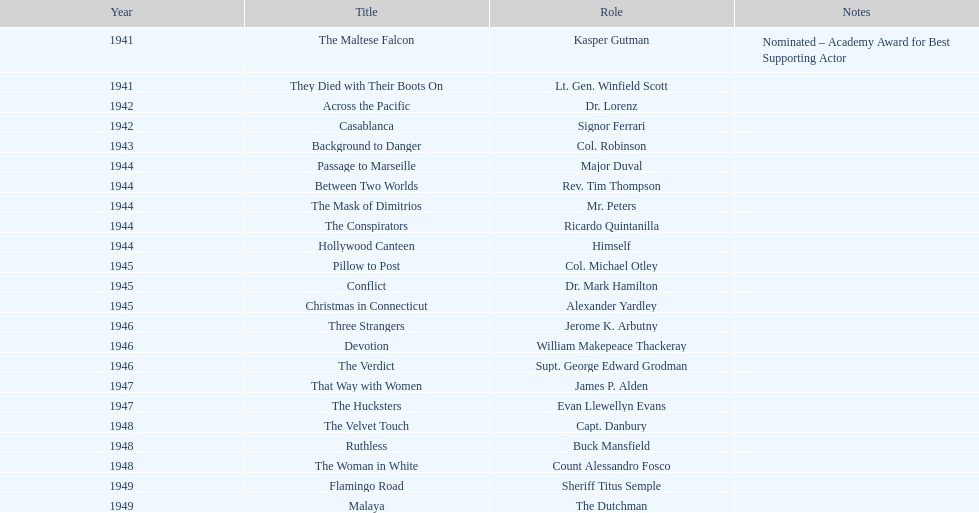What are all of the movies sydney greenstreet acted in? The Maltese Falcon, They Died with Their Boots On, Across the Pacific, Casablanca, Background to Danger, Passage to Marseille, Between Two Worlds, The Mask of Dimitrios, The Conspirators, Hollywood Canteen, Pillow to Post, Conflict, Christmas in Connecticut, Three Strangers, Devotion, The Verdict, That Way with Women, The Hucksters, The Velvet Touch, Ruthless, The Woman in White, Flamingo Road, Malaya. What are all of the title notes? Nominated – Academy Award for Best Supporting Actor. Which film was the award for? The Maltese Falcon. 